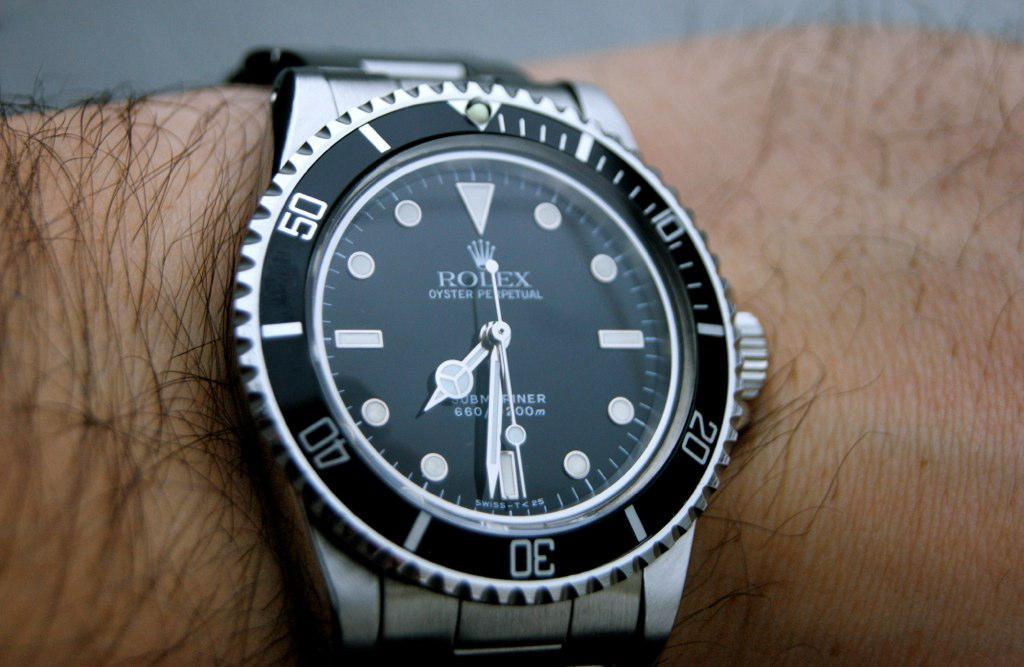<image>
Give a short and clear explanation of the subsequent image. A silver Rolex branded watch has the time of 7:31. 